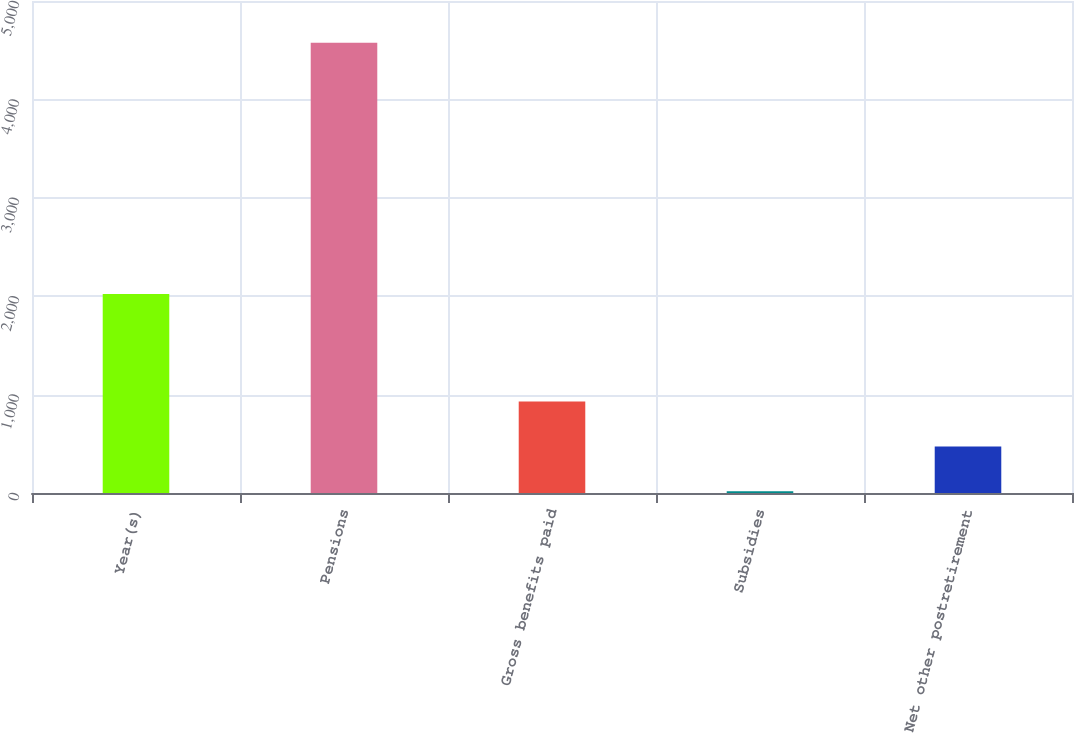<chart> <loc_0><loc_0><loc_500><loc_500><bar_chart><fcel>Year(s)<fcel>Pensions<fcel>Gross benefits paid<fcel>Subsidies<fcel>Net other postretirement<nl><fcel>2023<fcel>4575<fcel>929.4<fcel>18<fcel>473.7<nl></chart> 